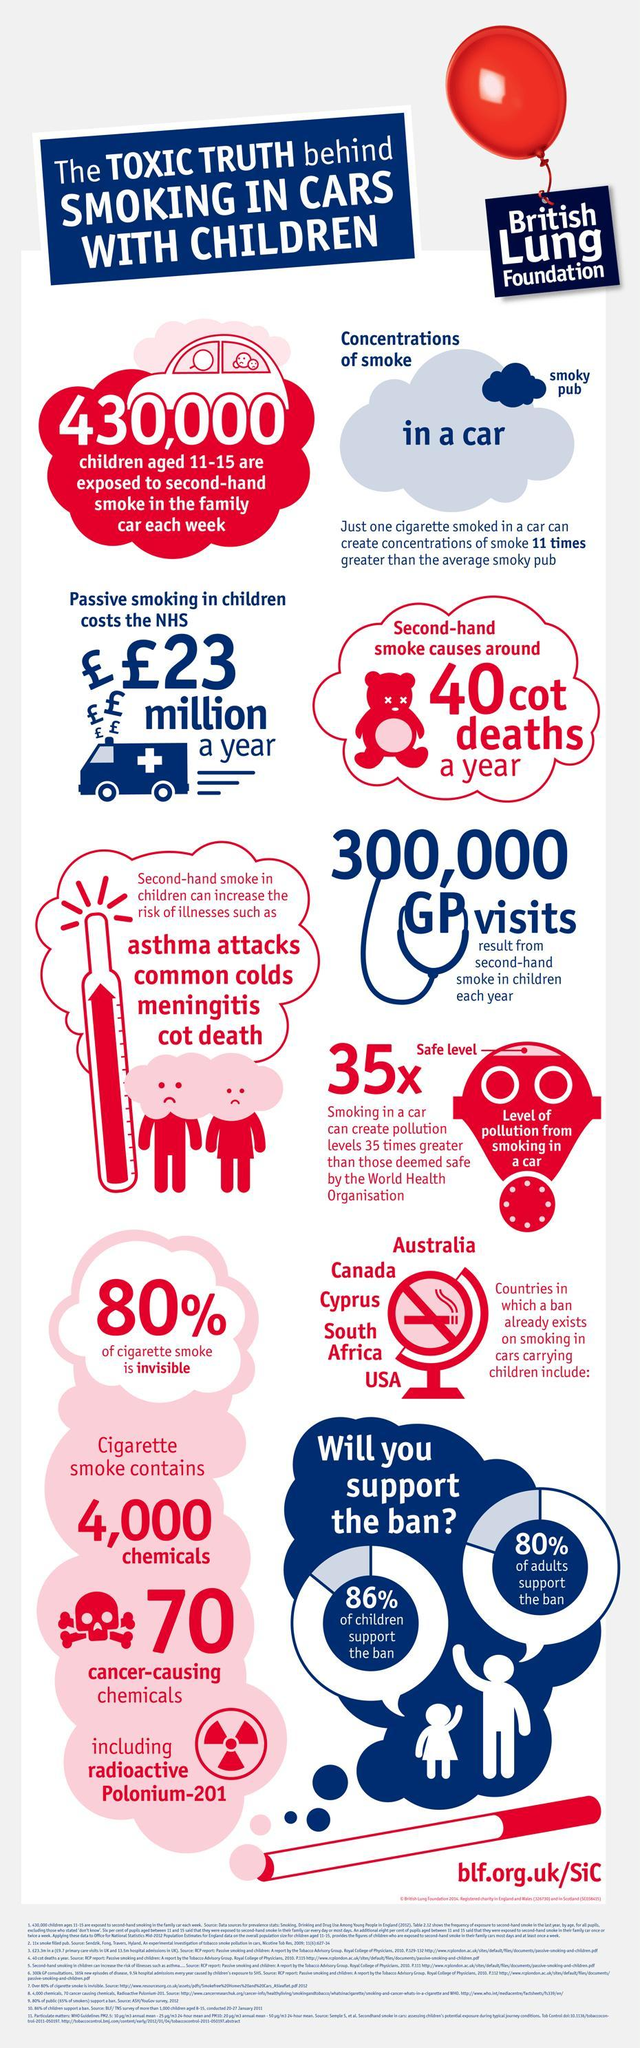How many cancer-causing chemicals are in cigarette smoke?
Answer the question with a short phrase. 70 What percentage of adults didn't support the cigarette ban? 20% How many chemicals are in cigarette smoke? 4000 What percentage of children didn't support the cigarette ban? 14% How many GP visits? 300,000 What percentage of cigarette smoke is visible? 20% 